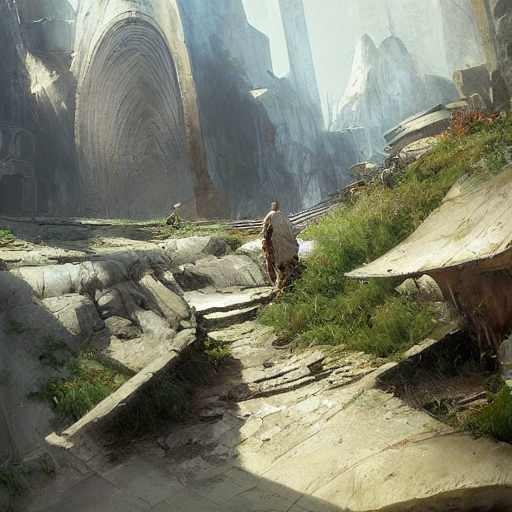What is the style of this artwork? The artwork appears to be a digital painting, likely designed to evoke a sense of exploration in a fantastical or ancient setting. It employs a realistic style with a focus on atmospheric perspective and a warm, earthy color palette. 